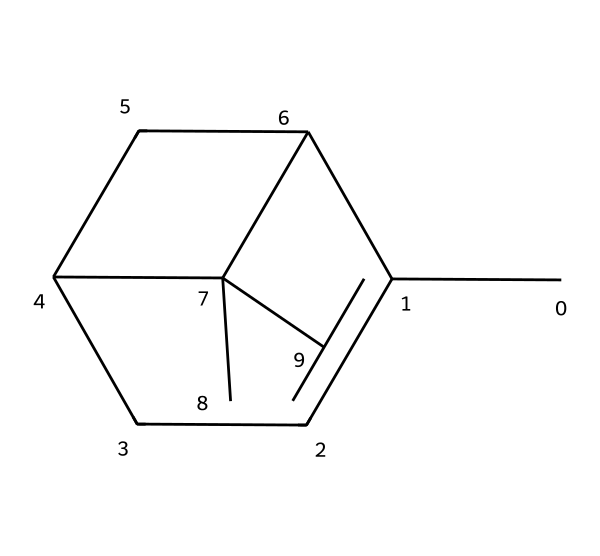What is the molecular formula of alpha-pinene? By analyzing the structure represented by the SMILES notation, we can deduce the molecular formula by counting the carbon (C) and hydrogen (H) atoms. The structure shows 10 carbon atoms and 16 hydrogen atoms. Therefore, the molecular formula is C10H16.
Answer: C10H16 How many rings are present in alpha-pinene? The SMILES notation reveals the connectivity and structure of the molecule, showing that alpha-pinene contains two fused cyclohexane rings, which can be identified by looking for ring closures (the numbers in the SMILES). Thus, there are two rings.
Answer: 2 What type of chemical structure is alpha-pinene classified as? Alpha-pinene is classified as a bicyclic monoterpene, as it consists of two interconnected rings and is derived from terpenes which are generally made of two or more isoprene units. This classification is evident from the molecular arrangement in the given SMILES.
Answer: bicyclic monoterpene How many double bonds does alpha-pinene have? Upon examining the structural representation in the SMILES, we identify the presence of one double bond between specific carbon atoms in the rings. Thus, there is one double bond in the molecule.
Answer: 1 What is the degree of unsaturation in alpha-pinene? To find the degree of unsaturation, we can use the general formula: Degree of Unsaturation = (2C + 2 + N - H - X)/2. Here, C = 10 (carbons), H = 16 (hydrogens), leading to a degree of unsaturation of 1, which corresponds to the single double bond and the ring structures.
Answer: 1 Is alpha-pinene chiral? Examining the structure revealed by the SMILES, we find that there are no stereogenic centers present in alpha-pinene, as all carbon atoms are either bonded to two identical groups or do not form any chiral centers. Thus, alpha-pinene is not chiral.
Answer: no 